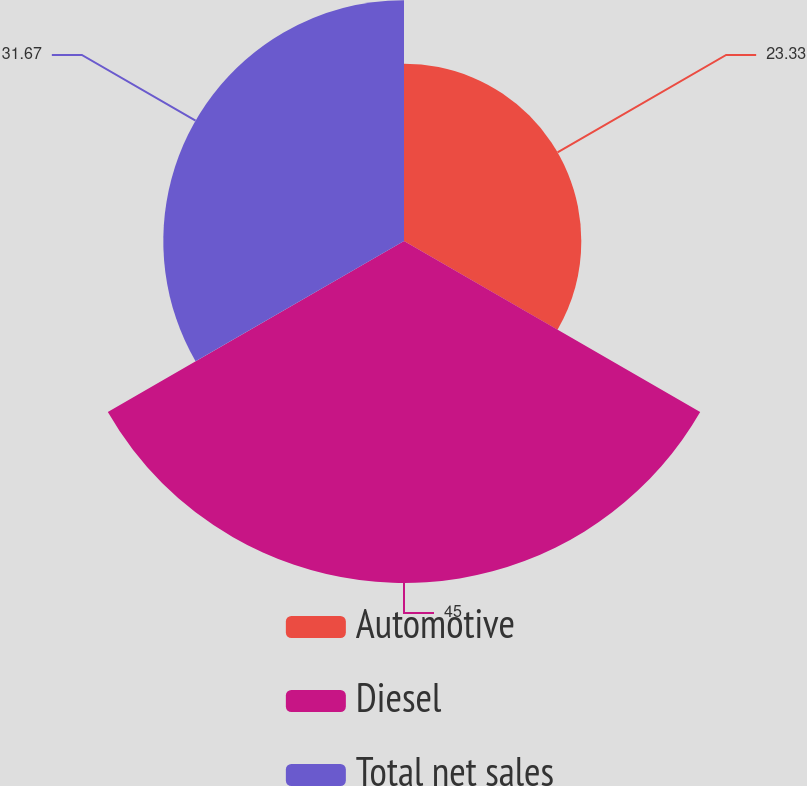Convert chart to OTSL. <chart><loc_0><loc_0><loc_500><loc_500><pie_chart><fcel>Automotive<fcel>Diesel<fcel>Total net sales<nl><fcel>23.33%<fcel>45.0%<fcel>31.67%<nl></chart> 